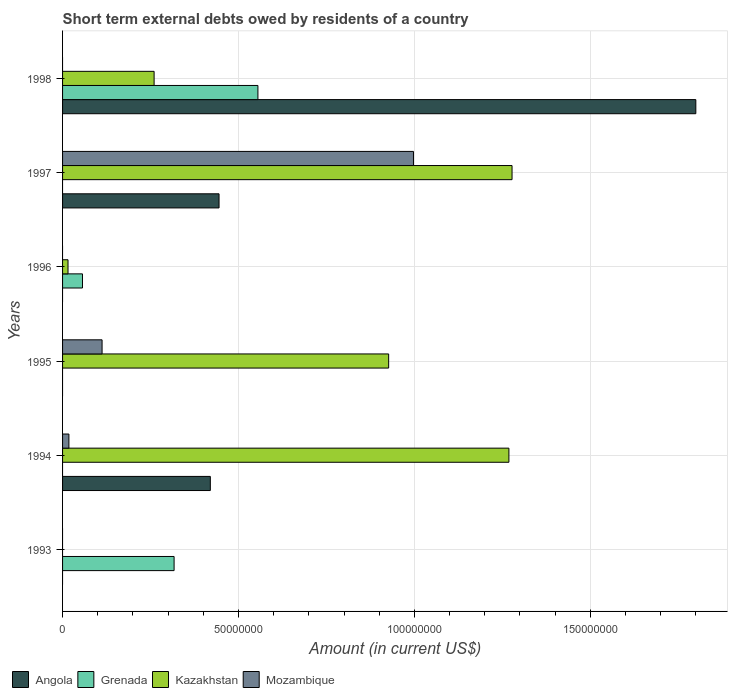How many different coloured bars are there?
Provide a succinct answer. 4. Are the number of bars on each tick of the Y-axis equal?
Offer a terse response. No. How many bars are there on the 4th tick from the top?
Offer a terse response. 2. What is the label of the 5th group of bars from the top?
Provide a short and direct response. 1994. In how many cases, is the number of bars for a given year not equal to the number of legend labels?
Your answer should be compact. 6. What is the amount of short-term external debts owed by residents in Kazakhstan in 1995?
Offer a very short reply. 9.27e+07. Across all years, what is the maximum amount of short-term external debts owed by residents in Grenada?
Provide a short and direct response. 5.55e+07. Across all years, what is the minimum amount of short-term external debts owed by residents in Mozambique?
Offer a very short reply. 0. What is the total amount of short-term external debts owed by residents in Grenada in the graph?
Your answer should be compact. 9.29e+07. What is the difference between the amount of short-term external debts owed by residents in Angola in 1997 and that in 1998?
Give a very brief answer. -1.36e+08. What is the difference between the amount of short-term external debts owed by residents in Kazakhstan in 1994 and the amount of short-term external debts owed by residents in Mozambique in 1997?
Ensure brevity in your answer.  2.71e+07. What is the average amount of short-term external debts owed by residents in Grenada per year?
Your answer should be very brief. 1.55e+07. In the year 1996, what is the difference between the amount of short-term external debts owed by residents in Grenada and amount of short-term external debts owed by residents in Kazakhstan?
Your response must be concise. 4.11e+06. What is the ratio of the amount of short-term external debts owed by residents in Grenada in 1996 to that in 1998?
Your answer should be very brief. 0.1. Is the amount of short-term external debts owed by residents in Mozambique in 1995 less than that in 1997?
Offer a terse response. Yes. Is the difference between the amount of short-term external debts owed by residents in Grenada in 1996 and 1998 greater than the difference between the amount of short-term external debts owed by residents in Kazakhstan in 1996 and 1998?
Your answer should be very brief. No. What is the difference between the highest and the second highest amount of short-term external debts owed by residents in Grenada?
Offer a very short reply. 2.38e+07. What is the difference between the highest and the lowest amount of short-term external debts owed by residents in Mozambique?
Your answer should be very brief. 9.97e+07. Is the sum of the amount of short-term external debts owed by residents in Kazakhstan in 1997 and 1998 greater than the maximum amount of short-term external debts owed by residents in Angola across all years?
Your response must be concise. No. Is it the case that in every year, the sum of the amount of short-term external debts owed by residents in Kazakhstan and amount of short-term external debts owed by residents in Angola is greater than the sum of amount of short-term external debts owed by residents in Mozambique and amount of short-term external debts owed by residents in Grenada?
Keep it short and to the point. No. Is it the case that in every year, the sum of the amount of short-term external debts owed by residents in Angola and amount of short-term external debts owed by residents in Mozambique is greater than the amount of short-term external debts owed by residents in Grenada?
Keep it short and to the point. No. How many bars are there?
Make the answer very short. 14. What is the difference between two consecutive major ticks on the X-axis?
Make the answer very short. 5.00e+07. Are the values on the major ticks of X-axis written in scientific E-notation?
Ensure brevity in your answer.  No. Does the graph contain any zero values?
Make the answer very short. Yes. Does the graph contain grids?
Keep it short and to the point. Yes. Where does the legend appear in the graph?
Your answer should be compact. Bottom left. How many legend labels are there?
Provide a succinct answer. 4. How are the legend labels stacked?
Provide a short and direct response. Horizontal. What is the title of the graph?
Offer a terse response. Short term external debts owed by residents of a country. What is the Amount (in current US$) of Angola in 1993?
Your response must be concise. 0. What is the Amount (in current US$) of Grenada in 1993?
Give a very brief answer. 3.17e+07. What is the Amount (in current US$) of Kazakhstan in 1993?
Your answer should be compact. 0. What is the Amount (in current US$) of Mozambique in 1993?
Give a very brief answer. 0. What is the Amount (in current US$) in Angola in 1994?
Ensure brevity in your answer.  4.20e+07. What is the Amount (in current US$) of Kazakhstan in 1994?
Keep it short and to the point. 1.27e+08. What is the Amount (in current US$) of Mozambique in 1994?
Provide a short and direct response. 1.80e+06. What is the Amount (in current US$) of Angola in 1995?
Your answer should be compact. 0. What is the Amount (in current US$) in Grenada in 1995?
Your answer should be very brief. 0. What is the Amount (in current US$) of Kazakhstan in 1995?
Give a very brief answer. 9.27e+07. What is the Amount (in current US$) in Mozambique in 1995?
Give a very brief answer. 1.12e+07. What is the Amount (in current US$) of Grenada in 1996?
Give a very brief answer. 5.66e+06. What is the Amount (in current US$) of Kazakhstan in 1996?
Offer a very short reply. 1.55e+06. What is the Amount (in current US$) of Mozambique in 1996?
Offer a terse response. 0. What is the Amount (in current US$) in Angola in 1997?
Offer a terse response. 4.45e+07. What is the Amount (in current US$) in Kazakhstan in 1997?
Your response must be concise. 1.28e+08. What is the Amount (in current US$) of Mozambique in 1997?
Your answer should be very brief. 9.97e+07. What is the Amount (in current US$) of Angola in 1998?
Keep it short and to the point. 1.80e+08. What is the Amount (in current US$) in Grenada in 1998?
Offer a terse response. 5.55e+07. What is the Amount (in current US$) of Kazakhstan in 1998?
Provide a short and direct response. 2.60e+07. What is the Amount (in current US$) in Mozambique in 1998?
Offer a terse response. 0. Across all years, what is the maximum Amount (in current US$) in Angola?
Your answer should be compact. 1.80e+08. Across all years, what is the maximum Amount (in current US$) in Grenada?
Offer a very short reply. 5.55e+07. Across all years, what is the maximum Amount (in current US$) of Kazakhstan?
Give a very brief answer. 1.28e+08. Across all years, what is the maximum Amount (in current US$) of Mozambique?
Provide a succinct answer. 9.97e+07. Across all years, what is the minimum Amount (in current US$) in Grenada?
Ensure brevity in your answer.  0. Across all years, what is the minimum Amount (in current US$) of Kazakhstan?
Offer a very short reply. 0. Across all years, what is the minimum Amount (in current US$) of Mozambique?
Ensure brevity in your answer.  0. What is the total Amount (in current US$) of Angola in the graph?
Provide a succinct answer. 2.66e+08. What is the total Amount (in current US$) of Grenada in the graph?
Your answer should be compact. 9.29e+07. What is the total Amount (in current US$) of Kazakhstan in the graph?
Make the answer very short. 3.75e+08. What is the total Amount (in current US$) of Mozambique in the graph?
Ensure brevity in your answer.  1.13e+08. What is the difference between the Amount (in current US$) of Grenada in 1993 and that in 1996?
Your answer should be compact. 2.60e+07. What is the difference between the Amount (in current US$) in Grenada in 1993 and that in 1998?
Keep it short and to the point. -2.38e+07. What is the difference between the Amount (in current US$) of Kazakhstan in 1994 and that in 1995?
Keep it short and to the point. 3.42e+07. What is the difference between the Amount (in current US$) in Mozambique in 1994 and that in 1995?
Your response must be concise. -9.43e+06. What is the difference between the Amount (in current US$) in Kazakhstan in 1994 and that in 1996?
Ensure brevity in your answer.  1.25e+08. What is the difference between the Amount (in current US$) in Angola in 1994 and that in 1997?
Make the answer very short. -2.48e+06. What is the difference between the Amount (in current US$) of Kazakhstan in 1994 and that in 1997?
Keep it short and to the point. -8.90e+05. What is the difference between the Amount (in current US$) of Mozambique in 1994 and that in 1997?
Keep it short and to the point. -9.79e+07. What is the difference between the Amount (in current US$) in Angola in 1994 and that in 1998?
Offer a very short reply. -1.38e+08. What is the difference between the Amount (in current US$) of Kazakhstan in 1994 and that in 1998?
Ensure brevity in your answer.  1.01e+08. What is the difference between the Amount (in current US$) of Kazakhstan in 1995 and that in 1996?
Offer a very short reply. 9.11e+07. What is the difference between the Amount (in current US$) in Kazakhstan in 1995 and that in 1997?
Your response must be concise. -3.51e+07. What is the difference between the Amount (in current US$) in Mozambique in 1995 and that in 1997?
Provide a succinct answer. -8.85e+07. What is the difference between the Amount (in current US$) in Kazakhstan in 1995 and that in 1998?
Ensure brevity in your answer.  6.67e+07. What is the difference between the Amount (in current US$) of Kazakhstan in 1996 and that in 1997?
Give a very brief answer. -1.26e+08. What is the difference between the Amount (in current US$) of Grenada in 1996 and that in 1998?
Give a very brief answer. -4.99e+07. What is the difference between the Amount (in current US$) in Kazakhstan in 1996 and that in 1998?
Give a very brief answer. -2.45e+07. What is the difference between the Amount (in current US$) in Angola in 1997 and that in 1998?
Give a very brief answer. -1.36e+08. What is the difference between the Amount (in current US$) in Kazakhstan in 1997 and that in 1998?
Offer a terse response. 1.02e+08. What is the difference between the Amount (in current US$) in Grenada in 1993 and the Amount (in current US$) in Kazakhstan in 1994?
Offer a very short reply. -9.52e+07. What is the difference between the Amount (in current US$) in Grenada in 1993 and the Amount (in current US$) in Mozambique in 1994?
Ensure brevity in your answer.  2.99e+07. What is the difference between the Amount (in current US$) in Grenada in 1993 and the Amount (in current US$) in Kazakhstan in 1995?
Your answer should be very brief. -6.10e+07. What is the difference between the Amount (in current US$) of Grenada in 1993 and the Amount (in current US$) of Mozambique in 1995?
Give a very brief answer. 2.05e+07. What is the difference between the Amount (in current US$) of Grenada in 1993 and the Amount (in current US$) of Kazakhstan in 1996?
Keep it short and to the point. 3.02e+07. What is the difference between the Amount (in current US$) of Grenada in 1993 and the Amount (in current US$) of Kazakhstan in 1997?
Make the answer very short. -9.61e+07. What is the difference between the Amount (in current US$) of Grenada in 1993 and the Amount (in current US$) of Mozambique in 1997?
Your answer should be very brief. -6.80e+07. What is the difference between the Amount (in current US$) in Grenada in 1993 and the Amount (in current US$) in Kazakhstan in 1998?
Your answer should be very brief. 5.68e+06. What is the difference between the Amount (in current US$) in Angola in 1994 and the Amount (in current US$) in Kazakhstan in 1995?
Your answer should be very brief. -5.07e+07. What is the difference between the Amount (in current US$) of Angola in 1994 and the Amount (in current US$) of Mozambique in 1995?
Provide a succinct answer. 3.08e+07. What is the difference between the Amount (in current US$) in Kazakhstan in 1994 and the Amount (in current US$) in Mozambique in 1995?
Your answer should be compact. 1.16e+08. What is the difference between the Amount (in current US$) of Angola in 1994 and the Amount (in current US$) of Grenada in 1996?
Provide a succinct answer. 3.63e+07. What is the difference between the Amount (in current US$) in Angola in 1994 and the Amount (in current US$) in Kazakhstan in 1996?
Provide a short and direct response. 4.04e+07. What is the difference between the Amount (in current US$) in Angola in 1994 and the Amount (in current US$) in Kazakhstan in 1997?
Give a very brief answer. -8.58e+07. What is the difference between the Amount (in current US$) of Angola in 1994 and the Amount (in current US$) of Mozambique in 1997?
Ensure brevity in your answer.  -5.77e+07. What is the difference between the Amount (in current US$) of Kazakhstan in 1994 and the Amount (in current US$) of Mozambique in 1997?
Your answer should be very brief. 2.71e+07. What is the difference between the Amount (in current US$) in Angola in 1994 and the Amount (in current US$) in Grenada in 1998?
Offer a very short reply. -1.35e+07. What is the difference between the Amount (in current US$) in Angola in 1994 and the Amount (in current US$) in Kazakhstan in 1998?
Ensure brevity in your answer.  1.60e+07. What is the difference between the Amount (in current US$) in Kazakhstan in 1995 and the Amount (in current US$) in Mozambique in 1997?
Offer a very short reply. -7.05e+06. What is the difference between the Amount (in current US$) in Grenada in 1996 and the Amount (in current US$) in Kazakhstan in 1997?
Make the answer very short. -1.22e+08. What is the difference between the Amount (in current US$) in Grenada in 1996 and the Amount (in current US$) in Mozambique in 1997?
Offer a terse response. -9.41e+07. What is the difference between the Amount (in current US$) of Kazakhstan in 1996 and the Amount (in current US$) of Mozambique in 1997?
Offer a terse response. -9.82e+07. What is the difference between the Amount (in current US$) in Grenada in 1996 and the Amount (in current US$) in Kazakhstan in 1998?
Offer a terse response. -2.04e+07. What is the difference between the Amount (in current US$) of Angola in 1997 and the Amount (in current US$) of Grenada in 1998?
Keep it short and to the point. -1.10e+07. What is the difference between the Amount (in current US$) in Angola in 1997 and the Amount (in current US$) in Kazakhstan in 1998?
Offer a very short reply. 1.85e+07. What is the average Amount (in current US$) of Angola per year?
Offer a terse response. 4.44e+07. What is the average Amount (in current US$) in Grenada per year?
Your answer should be very brief. 1.55e+07. What is the average Amount (in current US$) in Kazakhstan per year?
Ensure brevity in your answer.  6.25e+07. What is the average Amount (in current US$) of Mozambique per year?
Your response must be concise. 1.88e+07. In the year 1994, what is the difference between the Amount (in current US$) in Angola and Amount (in current US$) in Kazakhstan?
Provide a short and direct response. -8.49e+07. In the year 1994, what is the difference between the Amount (in current US$) of Angola and Amount (in current US$) of Mozambique?
Your answer should be compact. 4.02e+07. In the year 1994, what is the difference between the Amount (in current US$) of Kazakhstan and Amount (in current US$) of Mozambique?
Make the answer very short. 1.25e+08. In the year 1995, what is the difference between the Amount (in current US$) in Kazakhstan and Amount (in current US$) in Mozambique?
Your response must be concise. 8.15e+07. In the year 1996, what is the difference between the Amount (in current US$) of Grenada and Amount (in current US$) of Kazakhstan?
Make the answer very short. 4.11e+06. In the year 1997, what is the difference between the Amount (in current US$) of Angola and Amount (in current US$) of Kazakhstan?
Offer a terse response. -8.33e+07. In the year 1997, what is the difference between the Amount (in current US$) in Angola and Amount (in current US$) in Mozambique?
Ensure brevity in your answer.  -5.53e+07. In the year 1997, what is the difference between the Amount (in current US$) of Kazakhstan and Amount (in current US$) of Mozambique?
Your answer should be very brief. 2.80e+07. In the year 1998, what is the difference between the Amount (in current US$) in Angola and Amount (in current US$) in Grenada?
Provide a short and direct response. 1.24e+08. In the year 1998, what is the difference between the Amount (in current US$) in Angola and Amount (in current US$) in Kazakhstan?
Your answer should be very brief. 1.54e+08. In the year 1998, what is the difference between the Amount (in current US$) in Grenada and Amount (in current US$) in Kazakhstan?
Provide a succinct answer. 2.95e+07. What is the ratio of the Amount (in current US$) in Grenada in 1993 to that in 1996?
Ensure brevity in your answer.  5.6. What is the ratio of the Amount (in current US$) in Grenada in 1993 to that in 1998?
Ensure brevity in your answer.  0.57. What is the ratio of the Amount (in current US$) in Kazakhstan in 1994 to that in 1995?
Offer a very short reply. 1.37. What is the ratio of the Amount (in current US$) of Mozambique in 1994 to that in 1995?
Your answer should be very brief. 0.16. What is the ratio of the Amount (in current US$) of Kazakhstan in 1994 to that in 1996?
Offer a very short reply. 81.85. What is the ratio of the Amount (in current US$) of Angola in 1994 to that in 1997?
Your response must be concise. 0.94. What is the ratio of the Amount (in current US$) of Mozambique in 1994 to that in 1997?
Offer a terse response. 0.02. What is the ratio of the Amount (in current US$) of Angola in 1994 to that in 1998?
Offer a very short reply. 0.23. What is the ratio of the Amount (in current US$) of Kazakhstan in 1994 to that in 1998?
Ensure brevity in your answer.  4.88. What is the ratio of the Amount (in current US$) of Kazakhstan in 1995 to that in 1996?
Make the answer very short. 59.8. What is the ratio of the Amount (in current US$) in Kazakhstan in 1995 to that in 1997?
Provide a succinct answer. 0.73. What is the ratio of the Amount (in current US$) of Mozambique in 1995 to that in 1997?
Your answer should be compact. 0.11. What is the ratio of the Amount (in current US$) of Kazakhstan in 1995 to that in 1998?
Make the answer very short. 3.56. What is the ratio of the Amount (in current US$) of Kazakhstan in 1996 to that in 1997?
Make the answer very short. 0.01. What is the ratio of the Amount (in current US$) of Grenada in 1996 to that in 1998?
Make the answer very short. 0.1. What is the ratio of the Amount (in current US$) of Kazakhstan in 1996 to that in 1998?
Provide a succinct answer. 0.06. What is the ratio of the Amount (in current US$) in Angola in 1997 to that in 1998?
Provide a succinct answer. 0.25. What is the ratio of the Amount (in current US$) in Kazakhstan in 1997 to that in 1998?
Your answer should be compact. 4.91. What is the difference between the highest and the second highest Amount (in current US$) of Angola?
Offer a very short reply. 1.36e+08. What is the difference between the highest and the second highest Amount (in current US$) in Grenada?
Offer a very short reply. 2.38e+07. What is the difference between the highest and the second highest Amount (in current US$) in Kazakhstan?
Make the answer very short. 8.90e+05. What is the difference between the highest and the second highest Amount (in current US$) in Mozambique?
Ensure brevity in your answer.  8.85e+07. What is the difference between the highest and the lowest Amount (in current US$) of Angola?
Your answer should be very brief. 1.80e+08. What is the difference between the highest and the lowest Amount (in current US$) in Grenada?
Provide a short and direct response. 5.55e+07. What is the difference between the highest and the lowest Amount (in current US$) in Kazakhstan?
Keep it short and to the point. 1.28e+08. What is the difference between the highest and the lowest Amount (in current US$) of Mozambique?
Provide a short and direct response. 9.97e+07. 